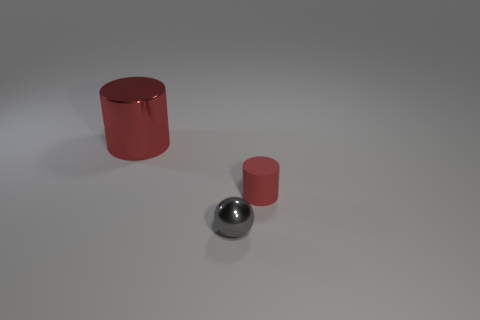There is another cylinder that is the same color as the matte cylinder; what size is it?
Provide a short and direct response. Large. Are there any small matte things that have the same color as the large metal object?
Keep it short and to the point. Yes. What is the size of the red thing behind the red cylinder right of the small thing that is to the left of the small red thing?
Offer a very short reply. Large. Does the big red shiny object have the same shape as the red matte object?
Provide a short and direct response. Yes. There is a small gray ball; are there any big red shiny things behind it?
Give a very brief answer. Yes. How many things are yellow rubber cubes or small gray metal objects?
Make the answer very short. 1. How many other objects are there of the same size as the matte cylinder?
Provide a short and direct response. 1. What number of cylinders are left of the small ball and in front of the large red metal thing?
Provide a succinct answer. 0. There is a red thing on the right side of the large red shiny thing; is it the same size as the cylinder that is to the left of the matte cylinder?
Ensure brevity in your answer.  No. There is a thing on the left side of the gray metal object; what size is it?
Your answer should be very brief. Large. 